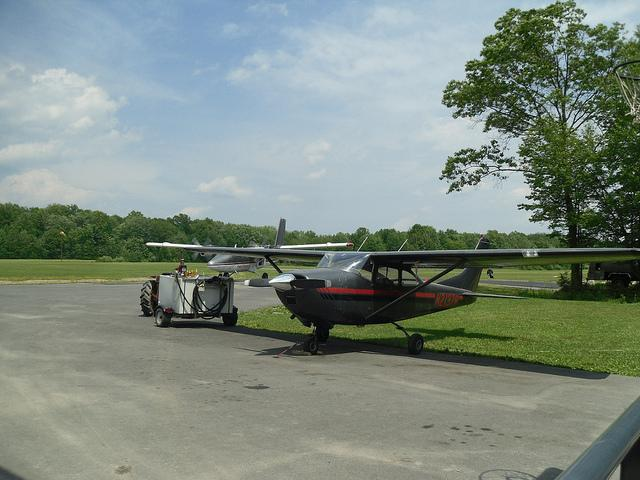What kind of transportation is shown?

Choices:
A) road
B) water
C) rail
D) air air 